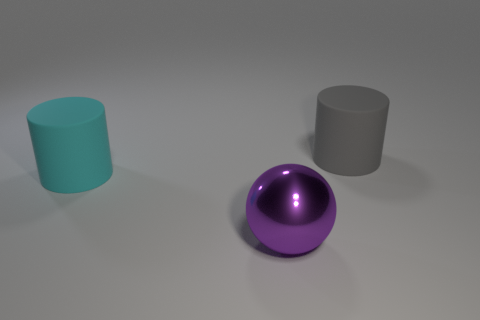Add 1 large cyan things. How many objects exist? 4 Subtract all spheres. How many objects are left? 2 Subtract 0 brown balls. How many objects are left? 3 Subtract all big matte objects. Subtract all purple spheres. How many objects are left? 0 Add 3 gray objects. How many gray objects are left? 4 Add 2 large purple matte cubes. How many large purple matte cubes exist? 2 